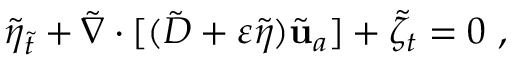<formula> <loc_0><loc_0><loc_500><loc_500>\tilde { \eta } _ { \tilde { t } } + \tilde { \nabla } \cdot [ ( \tilde { D } + \varepsilon \tilde { \eta } ) \tilde { u } _ { a } ] + \tilde { \zeta } _ { t } = 0 \ ,</formula> 